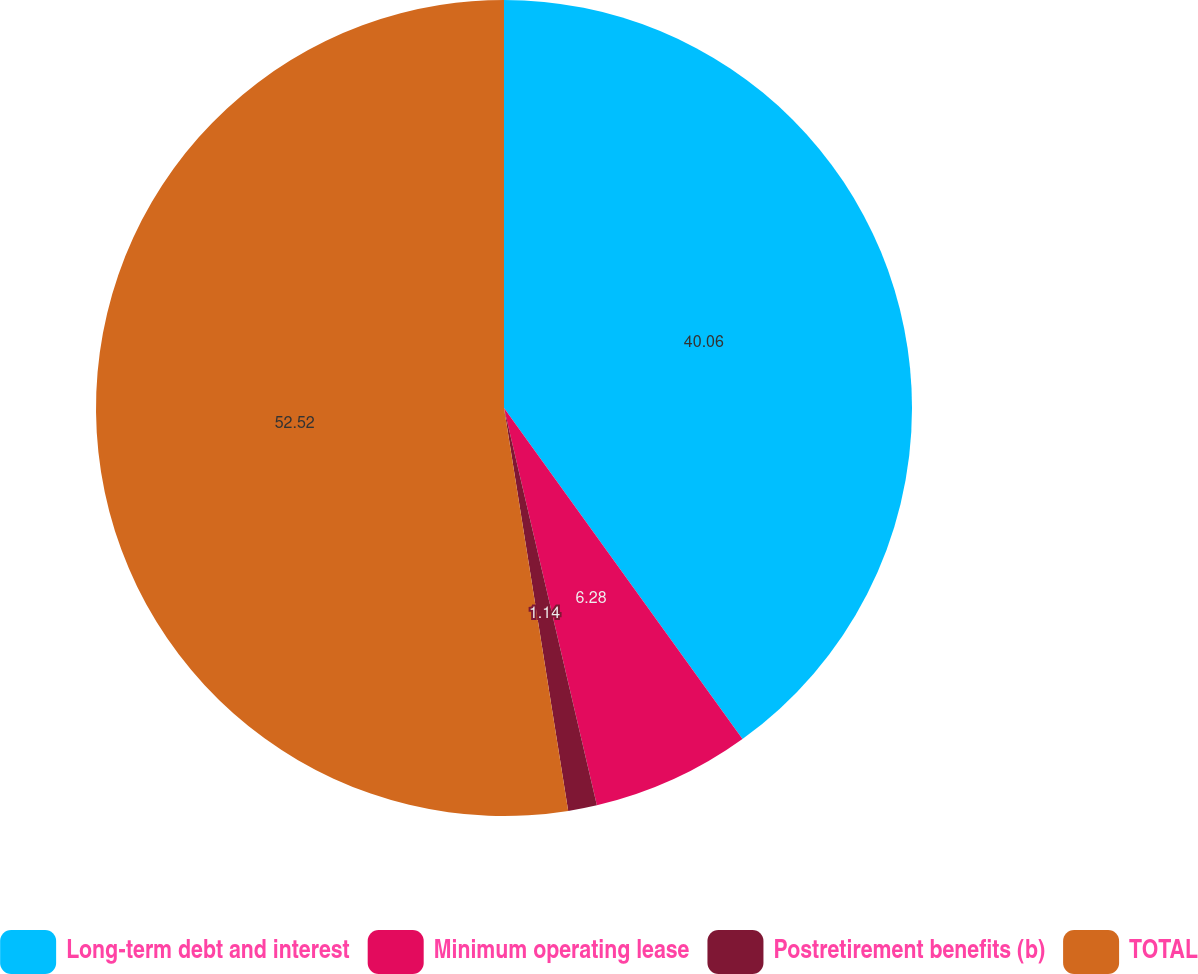Convert chart to OTSL. <chart><loc_0><loc_0><loc_500><loc_500><pie_chart><fcel>Long-term debt and interest<fcel>Minimum operating lease<fcel>Postretirement benefits (b)<fcel>TOTAL<nl><fcel>40.06%<fcel>6.28%<fcel>1.14%<fcel>52.51%<nl></chart> 